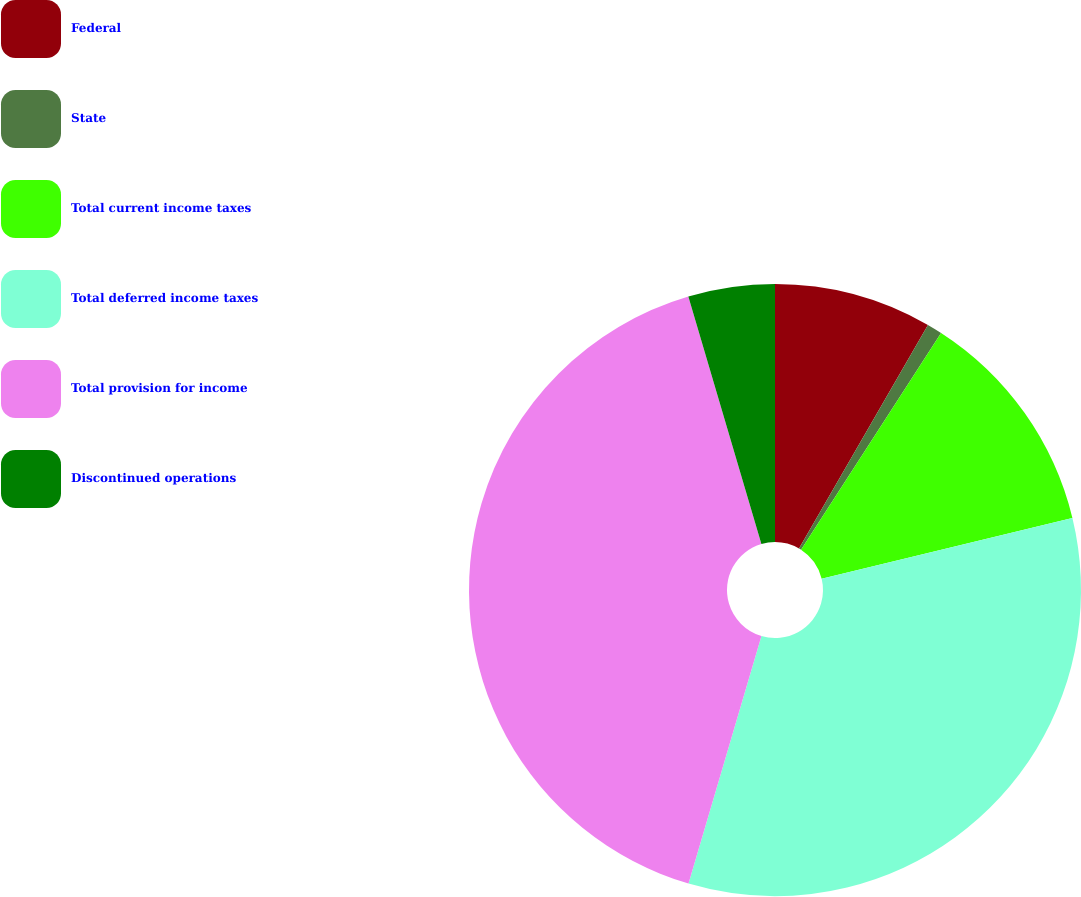<chart> <loc_0><loc_0><loc_500><loc_500><pie_chart><fcel>Federal<fcel>State<fcel>Total current income taxes<fcel>Total deferred income taxes<fcel>Total provision for income<fcel>Discontinued operations<nl><fcel>8.33%<fcel>0.8%<fcel>12.09%<fcel>33.34%<fcel>40.87%<fcel>4.57%<nl></chart> 